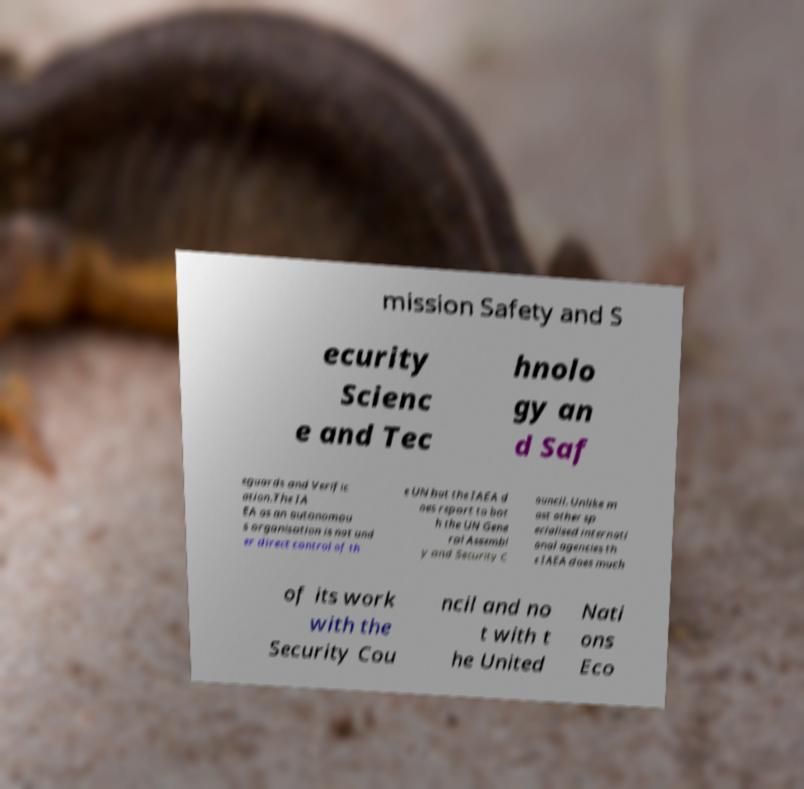For documentation purposes, I need the text within this image transcribed. Could you provide that? mission Safety and S ecurity Scienc e and Tec hnolo gy an d Saf eguards and Verific ation.The IA EA as an autonomou s organisation is not und er direct control of th e UN but the IAEA d oes report to bot h the UN Gene ral Assembl y and Security C ouncil. Unlike m ost other sp ecialised internati onal agencies th e IAEA does much of its work with the Security Cou ncil and no t with t he United Nati ons Eco 